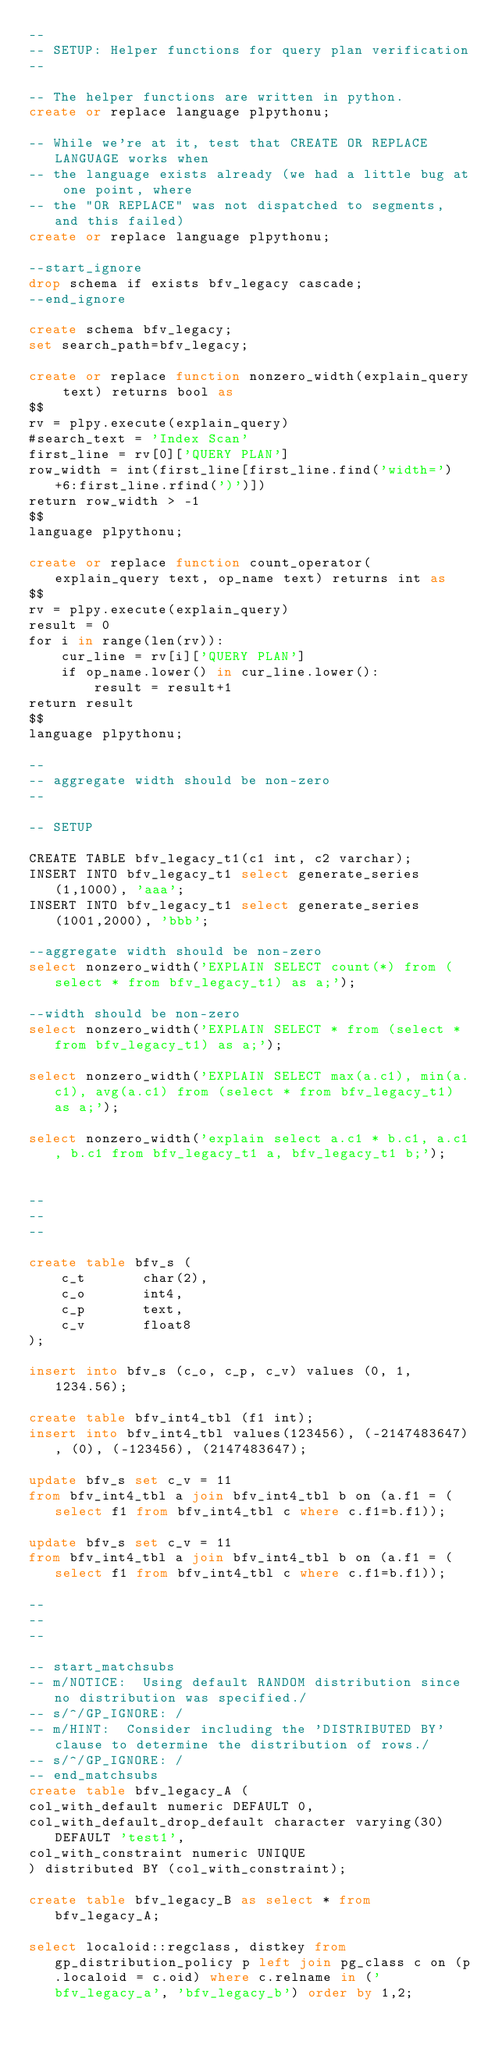Convert code to text. <code><loc_0><loc_0><loc_500><loc_500><_SQL_>--
-- SETUP: Helper functions for query plan verification
--

-- The helper functions are written in python.
create or replace language plpythonu;

-- While we're at it, test that CREATE OR REPLACE LANGUAGE works when
-- the language exists already (we had a little bug at one point, where
-- the "OR REPLACE" was not dispatched to segments, and this failed)
create or replace language plpythonu;

--start_ignore
drop schema if exists bfv_legacy cascade;
--end_ignore

create schema bfv_legacy;
set search_path=bfv_legacy;

create or replace function nonzero_width(explain_query text) returns bool as
$$
rv = plpy.execute(explain_query)
#search_text = 'Index Scan'
first_line = rv[0]['QUERY PLAN']
row_width = int(first_line[first_line.find('width=')+6:first_line.rfind(')')])
return row_width > -1
$$
language plpythonu;

create or replace function count_operator(explain_query text, op_name text) returns int as
$$
rv = plpy.execute(explain_query)
result = 0
for i in range(len(rv)):
    cur_line = rv[i]['QUERY PLAN']
    if op_name.lower() in cur_line.lower():
        result = result+1
return result
$$
language plpythonu;

--
-- aggregate width should be non-zero
--

-- SETUP

CREATE TABLE bfv_legacy_t1(c1 int, c2 varchar);
INSERT INTO bfv_legacy_t1 select generate_series(1,1000), 'aaa';
INSERT INTO bfv_legacy_t1 select generate_series(1001,2000), 'bbb';

--aggregate width should be non-zero
select nonzero_width('EXPLAIN SELECT count(*) from (select * from bfv_legacy_t1) as a;');

--width should be non-zero
select nonzero_width('EXPLAIN SELECT * from (select * from bfv_legacy_t1) as a;');

select nonzero_width('EXPLAIN SELECT max(a.c1), min(a.c1), avg(a.c1) from (select * from bfv_legacy_t1) as a;');

select nonzero_width('explain select a.c1 * b.c1, a.c1, b.c1 from bfv_legacy_t1 a, bfv_legacy_t1 b;');


--
--
--

create table bfv_s (
    c_t       char(2),
    c_o       int4,
    c_p       text,
    c_v       float8
);

insert into bfv_s (c_o, c_p, c_v) values (0, 1, 1234.56);

create table bfv_int4_tbl (f1 int);
insert into bfv_int4_tbl values(123456), (-2147483647), (0), (-123456), (2147483647);

update bfv_s set c_v = 11
from bfv_int4_tbl a join bfv_int4_tbl b on (a.f1 = (select f1 from bfv_int4_tbl c where c.f1=b.f1));

update bfv_s set c_v = 11
from bfv_int4_tbl a join bfv_int4_tbl b on (a.f1 = (select f1 from bfv_int4_tbl c where c.f1=b.f1));

--
--
--

-- start_matchsubs
-- m/NOTICE:  Using default RANDOM distribution since no distribution was specified./
-- s/^/GP_IGNORE: /
-- m/HINT:  Consider including the 'DISTRIBUTED BY' clause to determine the distribution of rows./
-- s/^/GP_IGNORE: /
-- end_matchsubs
create table bfv_legacy_A (
col_with_default numeric DEFAULT 0,
col_with_default_drop_default character varying(30) DEFAULT 'test1',
col_with_constraint numeric UNIQUE
) distributed BY (col_with_constraint);

create table bfv_legacy_B as select * from bfv_legacy_A;

select localoid::regclass, distkey from gp_distribution_policy p left join pg_class c on (p.localoid = c.oid) where c.relname in ('bfv_legacy_a', 'bfv_legacy_b') order by 1,2;
</code> 